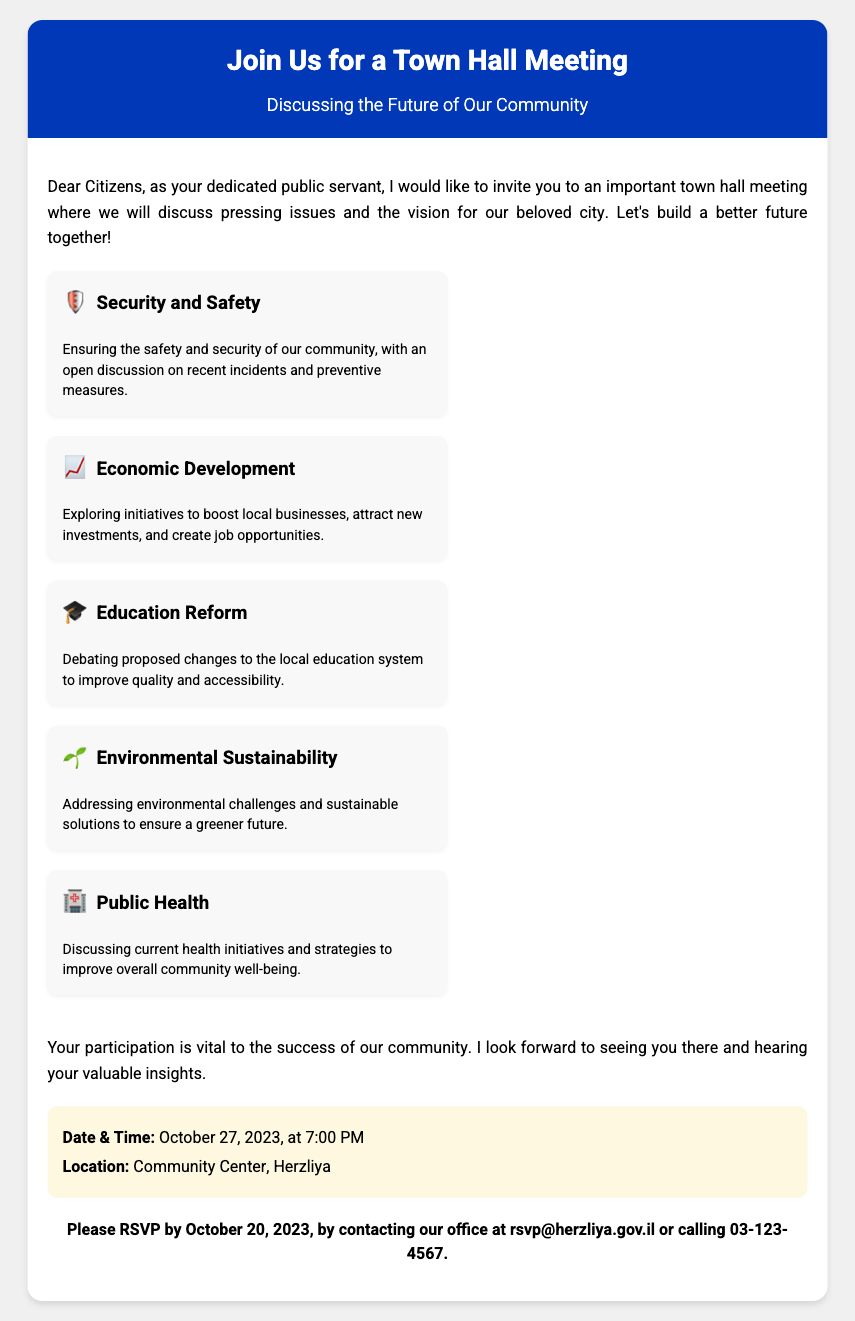what is the date of the town hall meeting? The document states the town hall meeting is scheduled for October 27, 2023.
Answer: October 27, 2023 what is the location of the meeting? The location specified in the document is the Community Center in Herzliya.
Answer: Community Center, Herzliya what time will the town hall meeting start? According to the document, the meeting will start at 7:00 PM.
Answer: 7:00 PM which topic is related to local businesses? The document highlights "Economic Development" as a topic related to local businesses.
Answer: Economic Development what is the RSVP deadline? The RSVP deadline mentioned in the document is October 20, 2023.
Answer: October 20, 2023 how many key points are discussed in the meeting? The document lists five key points regarding the discussion topics for the meeting.
Answer: Five what does the first key point address? The first key point in the document addresses "Security and Safety".
Answer: Security and Safety who is invited to the meeting? The invitation in the document is addressed to "Dear Citizens".
Answer: Citizens what should participants do to RSVP? The document instructs participants to contact the office via email or phone to RSVP.
Answer: Email or phone 